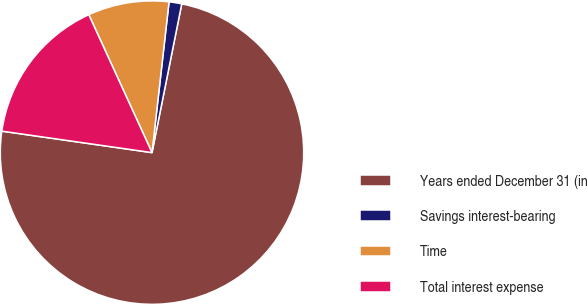Convert chart. <chart><loc_0><loc_0><loc_500><loc_500><pie_chart><fcel>Years ended December 31 (in<fcel>Savings interest-bearing<fcel>Time<fcel>Total interest expense<nl><fcel>74.12%<fcel>1.35%<fcel>8.63%<fcel>15.9%<nl></chart> 